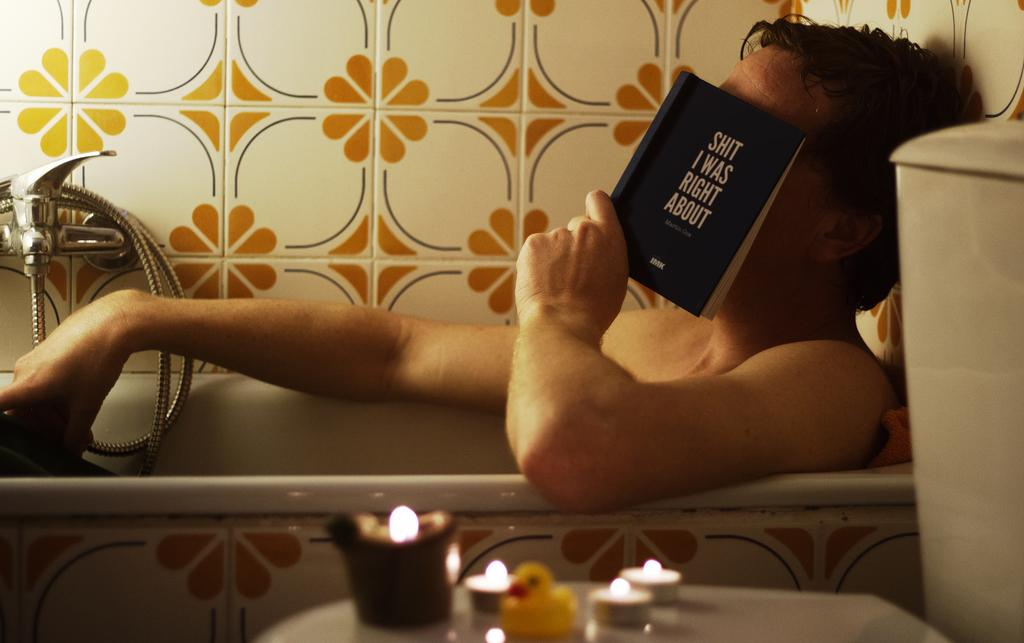<image>
Render a clear and concise summary of the photo. A man is reading a book in the bathtub about things someone was right about. 